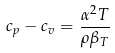<formula> <loc_0><loc_0><loc_500><loc_500>c _ { p } - c _ { v } = \frac { \alpha ^ { 2 } T } { \rho \beta _ { T } }</formula> 